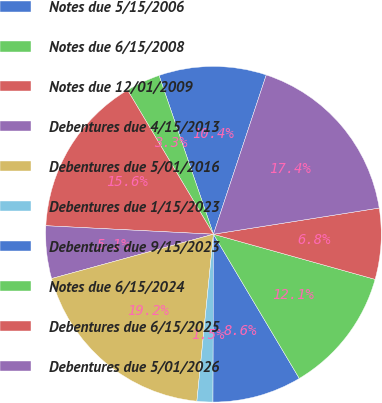Convert chart to OTSL. <chart><loc_0><loc_0><loc_500><loc_500><pie_chart><fcel>Notes due 5/15/2006<fcel>Notes due 6/15/2008<fcel>Notes due 12/01/2009<fcel>Debentures due 4/15/2013<fcel>Debentures due 5/01/2016<fcel>Debentures due 1/15/2023<fcel>Debentures due 9/15/2023<fcel>Notes due 6/15/2024<fcel>Debentures due 6/15/2025<fcel>Debentures due 5/01/2026<nl><fcel>10.35%<fcel>3.3%<fcel>15.64%<fcel>5.06%<fcel>19.17%<fcel>1.53%<fcel>8.59%<fcel>12.12%<fcel>6.83%<fcel>17.41%<nl></chart> 